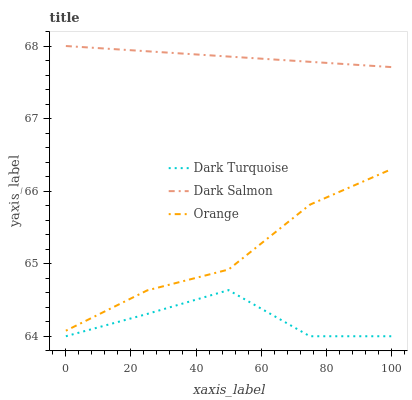Does Dark Turquoise have the minimum area under the curve?
Answer yes or no. Yes. Does Dark Salmon have the maximum area under the curve?
Answer yes or no. Yes. Does Dark Salmon have the minimum area under the curve?
Answer yes or no. No. Does Dark Turquoise have the maximum area under the curve?
Answer yes or no. No. Is Dark Salmon the smoothest?
Answer yes or no. Yes. Is Dark Turquoise the roughest?
Answer yes or no. Yes. Is Dark Turquoise the smoothest?
Answer yes or no. No. Is Dark Salmon the roughest?
Answer yes or no. No. Does Dark Turquoise have the lowest value?
Answer yes or no. Yes. Does Dark Salmon have the lowest value?
Answer yes or no. No. Does Dark Salmon have the highest value?
Answer yes or no. Yes. Does Dark Turquoise have the highest value?
Answer yes or no. No. Is Dark Turquoise less than Dark Salmon?
Answer yes or no. Yes. Is Dark Salmon greater than Dark Turquoise?
Answer yes or no. Yes. Does Dark Turquoise intersect Dark Salmon?
Answer yes or no. No. 